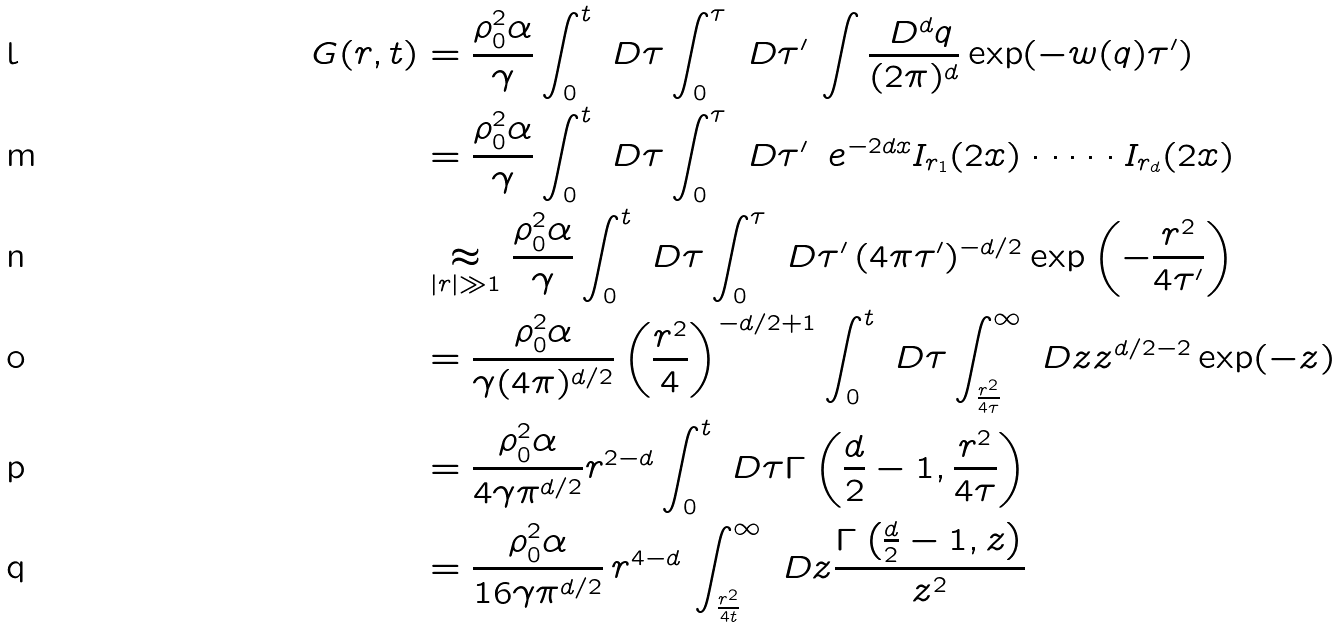<formula> <loc_0><loc_0><loc_500><loc_500>G ( { r } , t ) & = \frac { \rho _ { 0 } ^ { 2 } \alpha } { \gamma } \int _ { 0 } ^ { t } \ D \tau \int _ { 0 } ^ { \tau } \ D \tau ^ { \prime } \, \int \frac { \ D ^ { d } { q } } { ( 2 \pi ) ^ { d } } \exp ( - w ( { q } ) \tau ^ { \prime } ) \\ & = \frac { \rho _ { 0 } ^ { 2 } \alpha } { \gamma } \int _ { 0 } ^ { t } \ D \tau \int _ { 0 } ^ { \tau } \ D \tau ^ { \prime } \, \ e ^ { - 2 d x } I _ { r _ { 1 } } ( 2 x ) \cdot \dots \cdot I _ { r _ { d } } ( 2 x ) \\ & \underset { | { r } | \gg 1 } { \approx } \frac { \rho _ { 0 } ^ { 2 } \alpha } { \gamma } \int _ { 0 } ^ { t } \ D \tau \int _ { 0 } ^ { \tau } \ D \tau ^ { \prime } \, ( 4 \pi \tau ^ { \prime } ) ^ { - d / 2 } \exp \left ( - \frac { r ^ { 2 } } { 4 \tau ^ { \prime } } \right ) \\ & = \frac { \rho _ { 0 } ^ { 2 } \alpha } { \gamma ( 4 \pi ) ^ { d / 2 } } \left ( \frac { r ^ { 2 } } { 4 } \right ) ^ { - d / 2 + 1 } \int _ { 0 } ^ { t } \ D \tau \int _ { \frac { r ^ { 2 } } { 4 \tau } } ^ { \infty } \ D z z ^ { d / 2 - 2 } \exp ( - z ) \\ & = \frac { \rho _ { 0 } ^ { 2 } \alpha } { 4 \gamma \pi ^ { d / 2 } } r ^ { 2 - d } \int _ { 0 } ^ { t } \ D \tau \Gamma \left ( \frac { d } { 2 } - 1 , \frac { r ^ { 2 } } { 4 \tau } \right ) \\ & = \frac { \rho _ { 0 } ^ { 2 } \alpha } { 1 6 \gamma \pi ^ { d / 2 } } \, r ^ { 4 - d } \, \int _ { \frac { r ^ { 2 } } { 4 t } } ^ { \infty } \ D z \frac { \Gamma \left ( \frac { d } { 2 } - 1 , z \right ) } { z ^ { 2 } }</formula> 